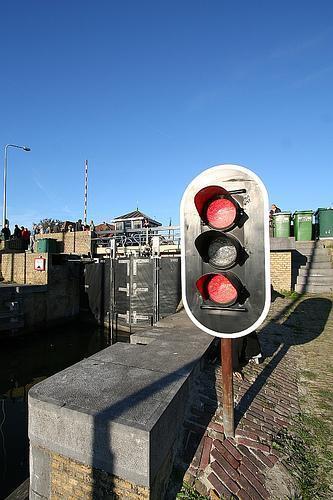How many horses are pictured?
Give a very brief answer. 0. 